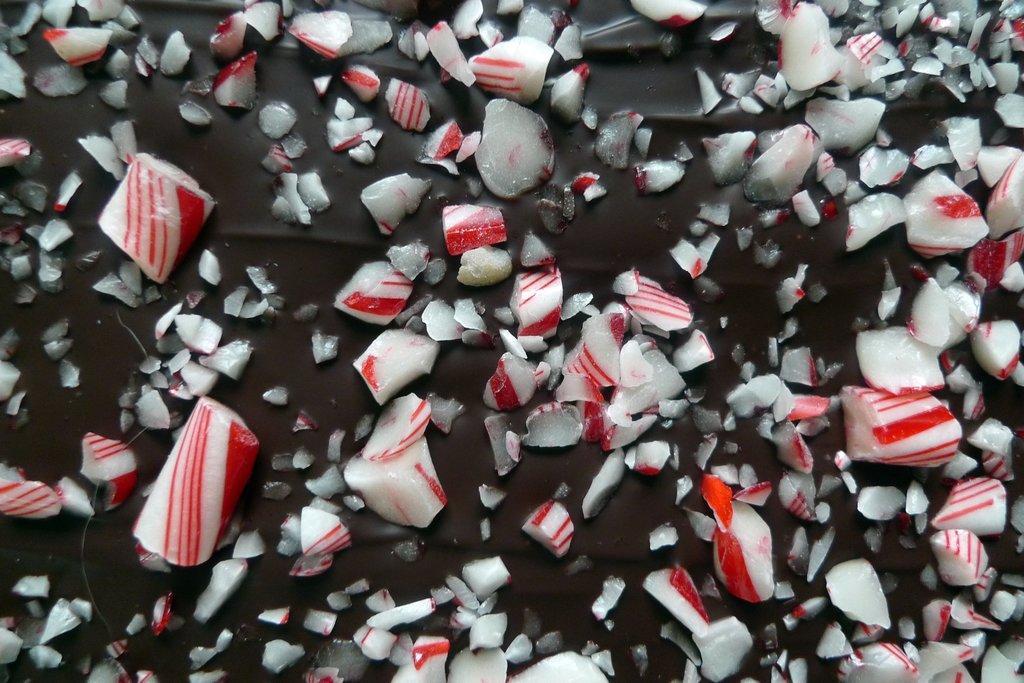In one or two sentences, can you explain what this image depicts? In this image, we can see a chocolate with pieces of candy over all the image. 